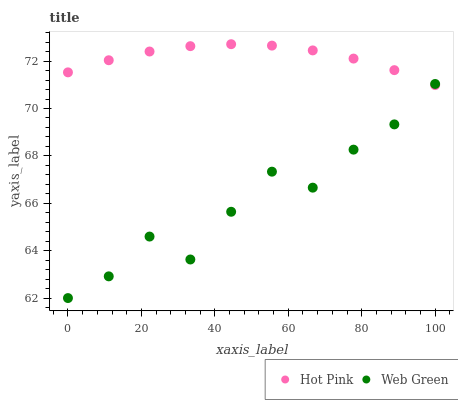Does Web Green have the minimum area under the curve?
Answer yes or no. Yes. Does Hot Pink have the maximum area under the curve?
Answer yes or no. Yes. Does Web Green have the maximum area under the curve?
Answer yes or no. No. Is Hot Pink the smoothest?
Answer yes or no. Yes. Is Web Green the roughest?
Answer yes or no. Yes. Is Web Green the smoothest?
Answer yes or no. No. Does Web Green have the lowest value?
Answer yes or no. Yes. Does Hot Pink have the highest value?
Answer yes or no. Yes. Does Web Green have the highest value?
Answer yes or no. No. Does Hot Pink intersect Web Green?
Answer yes or no. Yes. Is Hot Pink less than Web Green?
Answer yes or no. No. Is Hot Pink greater than Web Green?
Answer yes or no. No. 